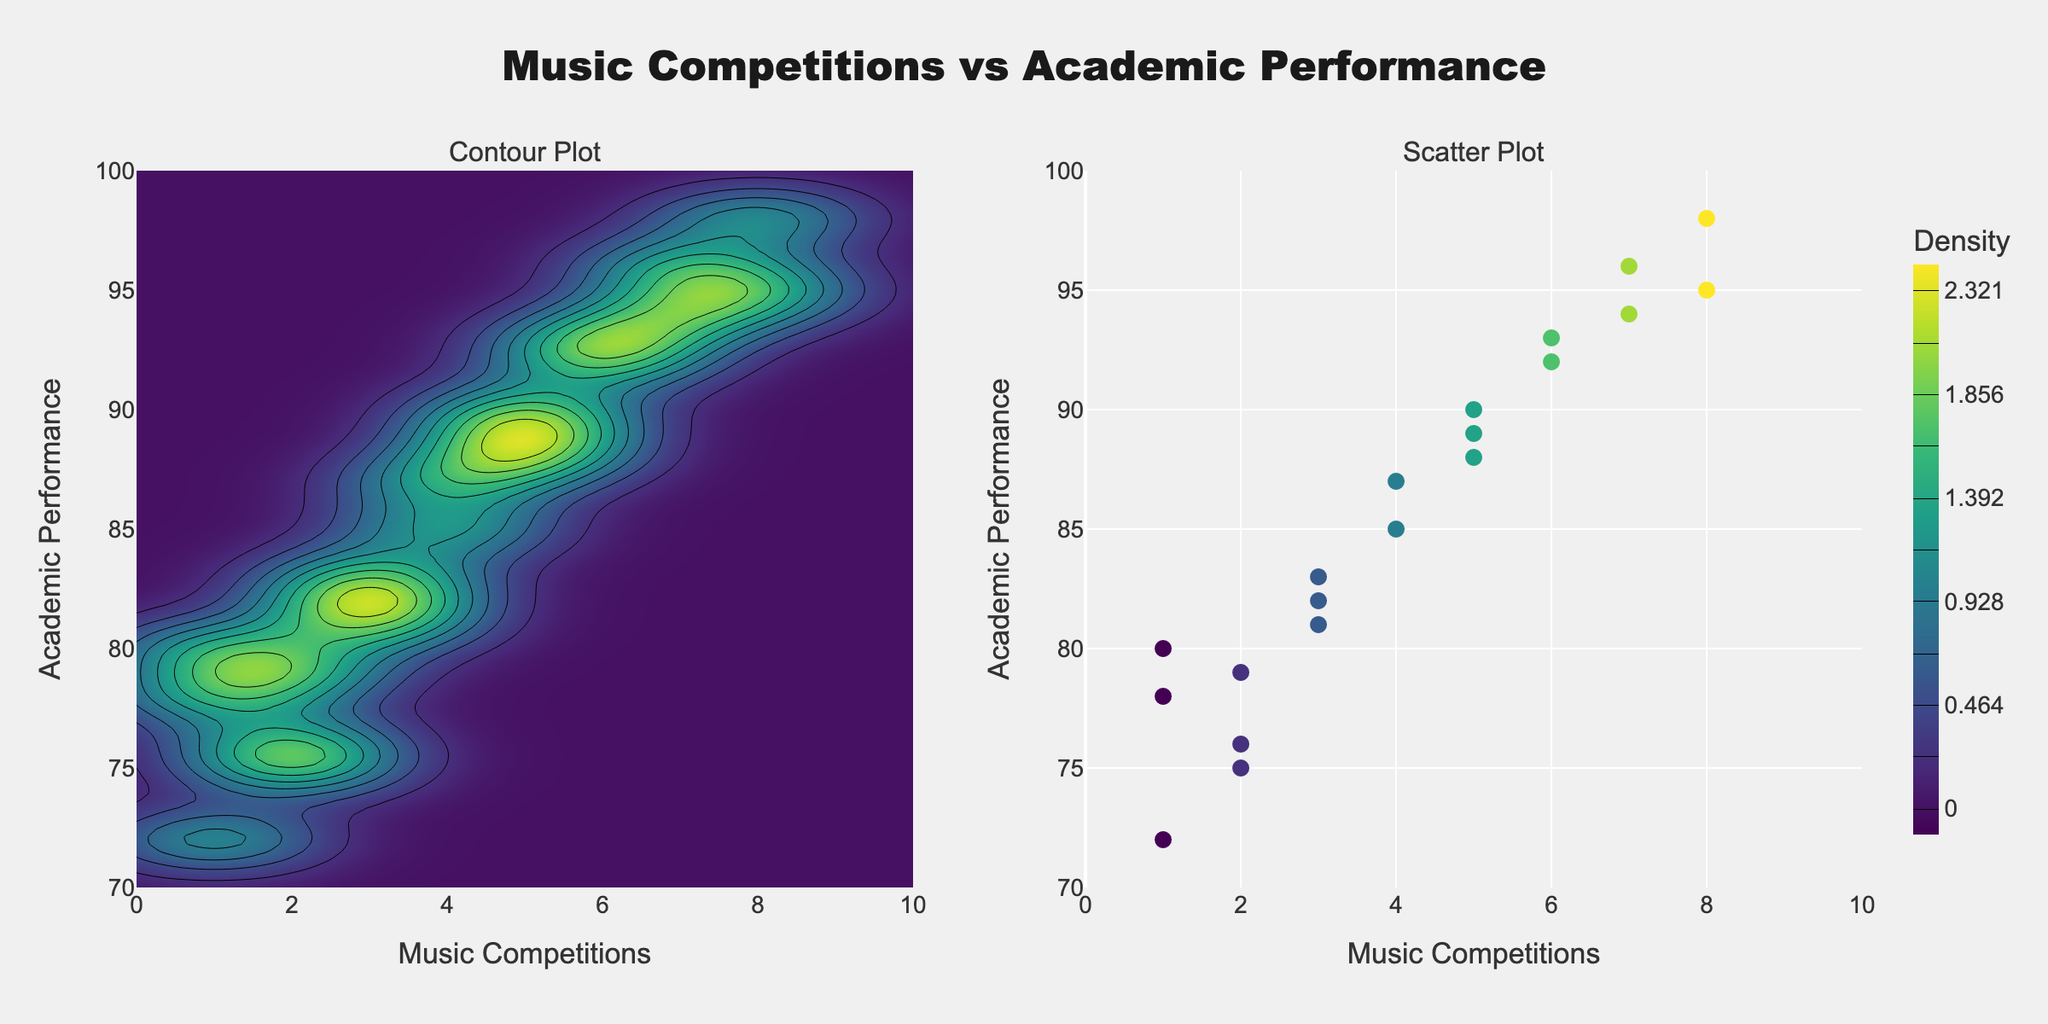What is the title of the figure? The title is often displayed prominently at the top of the figure. In this case, it clearly states, "Music Competitions vs Academic Performance."
Answer: Music Competitions vs Academic Performance What are the labels of the x and y axes in the contour plot? The x-axis and y-axis labels are derived from the data being visualized. The x-axis represents "Music Competitions," and the y-axis represents "Academic Performance."
Answer: Music Competitions and Academic Performance How many subplots are there in the figure? The figure description states that there are two subplots: one contour plot and one scatter plot. This is visually confirmed by the presence of two distinct plot areas in the figure.
Answer: Two Which subplot shows a heatmap? Heatmaps are typically represented with varying colors to indicate different density values. In this figure, the contour plot on the left shows a heatmap.
Answer: The contour plot How many students have participated in 5 music competitions? By looking at the scatter plot on the right, you can see how multiple markers stack up at certain x-values. For 5 competitions, four markers (Alice, Liam, Tom, and another unlisted) are visible.
Answer: Four What is the student count for academic performance over 90? To find this, you count how many points lie above the y-value of 90 in the scatter plot. Using this method, six students (Charlie, George, Ivy, Liam, Nolan, Olivia, Sophia) fit the criteria.
Answer: Six Which student participated in the highest number of music competitions and what was their academic performance? Sorting through the scatter plot, the highest x-value (8 competitions) indicates two students (Charlie and Sophia) participated most. By their y-values, their performances are 95 and 98, respectively, so Sophia had the highest academic performance, competing equally with Charlie.
Answer: Sophia, 98 Is there an apparent correlation between participation in music competitions and academic performance from the scatter plot? By observing how the dots disperse and align, you can gauge this. Here, the dots generally form an upward trend, indicating that increased participation is often associated with higher academic performance.
Answer: Yes What color scale is used in the contour plot to represent density? The figure explicitly uses the 'Viridis' colorscale, which usually ranges from dark blue to yellow in this context.
Answer: Viridis What's the approximate range of academic performance for students who have taken part in 3 music competitions? Locating markers on the x=3 vertical line in the scatter plot, the y-values range between roughly 81 and 83 (markers like Daisy, Kelly, and Quincy).
Answer: 81 to 83 